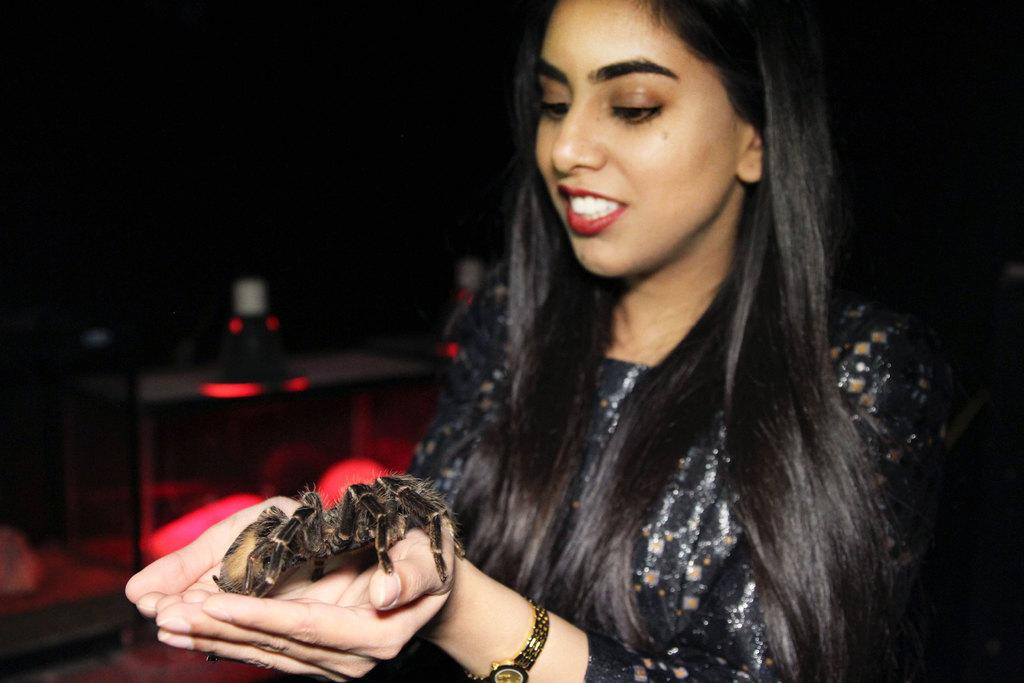Who is present in the image? There is a woman in the image. What is the woman holding? The woman is holding a Scorpio. What can be seen in the background of the image? There is a table in the image. What is on the table? There are objects on the table. What type of honey can be seen dripping from the carriage in the image? There is no honey or carriage present in the image. 